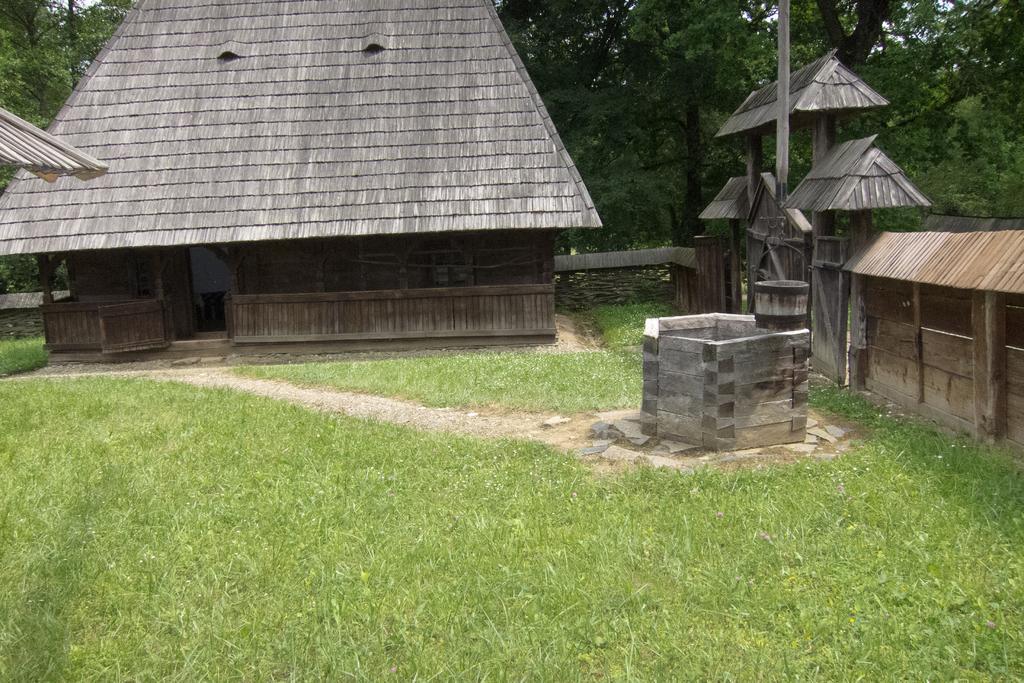Can you describe this image briefly? In this picture I can observe house in the middle of the picture. There is some grass on the ground. In the background there are trees. 